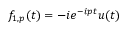<formula> <loc_0><loc_0><loc_500><loc_500>\begin{array} { r } { f _ { 1 , p } ( t ) = - i e ^ { - i p t } u ( t ) } \end{array}</formula> 